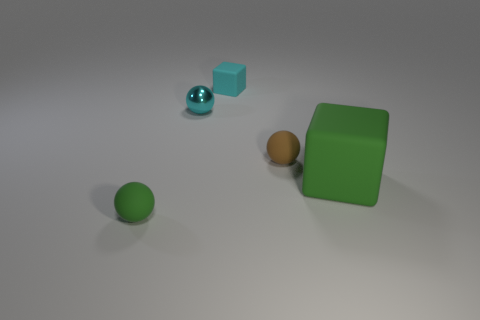Is there a small metallic thing behind the tiny cyan matte block to the left of the matte ball that is behind the green matte ball?
Your answer should be very brief. No. Are there fewer large green things than green rubber cylinders?
Provide a succinct answer. No. Do the green object on the right side of the tiny shiny ball and the tiny cyan metal object have the same shape?
Make the answer very short. No. Are any yellow cylinders visible?
Your answer should be compact. No. The tiny rubber ball right of the thing that is to the left of the sphere that is behind the brown thing is what color?
Offer a very short reply. Brown. Is the number of green rubber blocks that are to the right of the large green matte thing the same as the number of small cyan spheres right of the tiny cyan matte thing?
Your response must be concise. Yes. There is another cyan thing that is the same size as the cyan matte thing; what is its shape?
Make the answer very short. Sphere. Is there another thing of the same color as the small metallic thing?
Ensure brevity in your answer.  Yes. What shape is the matte object behind the small brown matte object?
Make the answer very short. Cube. What color is the large block?
Your answer should be compact. Green. 